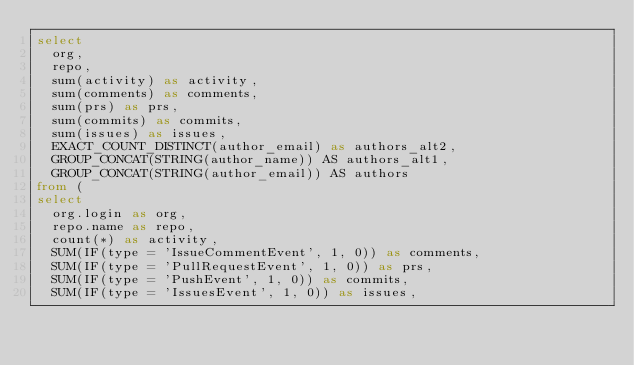Convert code to text. <code><loc_0><loc_0><loc_500><loc_500><_SQL_>select
  org,
  repo,
  sum(activity) as activity,
  sum(comments) as comments,
  sum(prs) as prs,
  sum(commits) as commits,
  sum(issues) as issues,
  EXACT_COUNT_DISTINCT(author_email) as authors_alt2,
  GROUP_CONCAT(STRING(author_name)) AS authors_alt1,
  GROUP_CONCAT(STRING(author_email)) AS authors
from (
select
  org.login as org,
  repo.name as repo,
  count(*) as activity,
  SUM(IF(type = 'IssueCommentEvent', 1, 0)) as comments,
  SUM(IF(type = 'PullRequestEvent', 1, 0)) as prs,
  SUM(IF(type = 'PushEvent', 1, 0)) as commits,
  SUM(IF(type = 'IssuesEvent', 1, 0)) as issues,</code> 